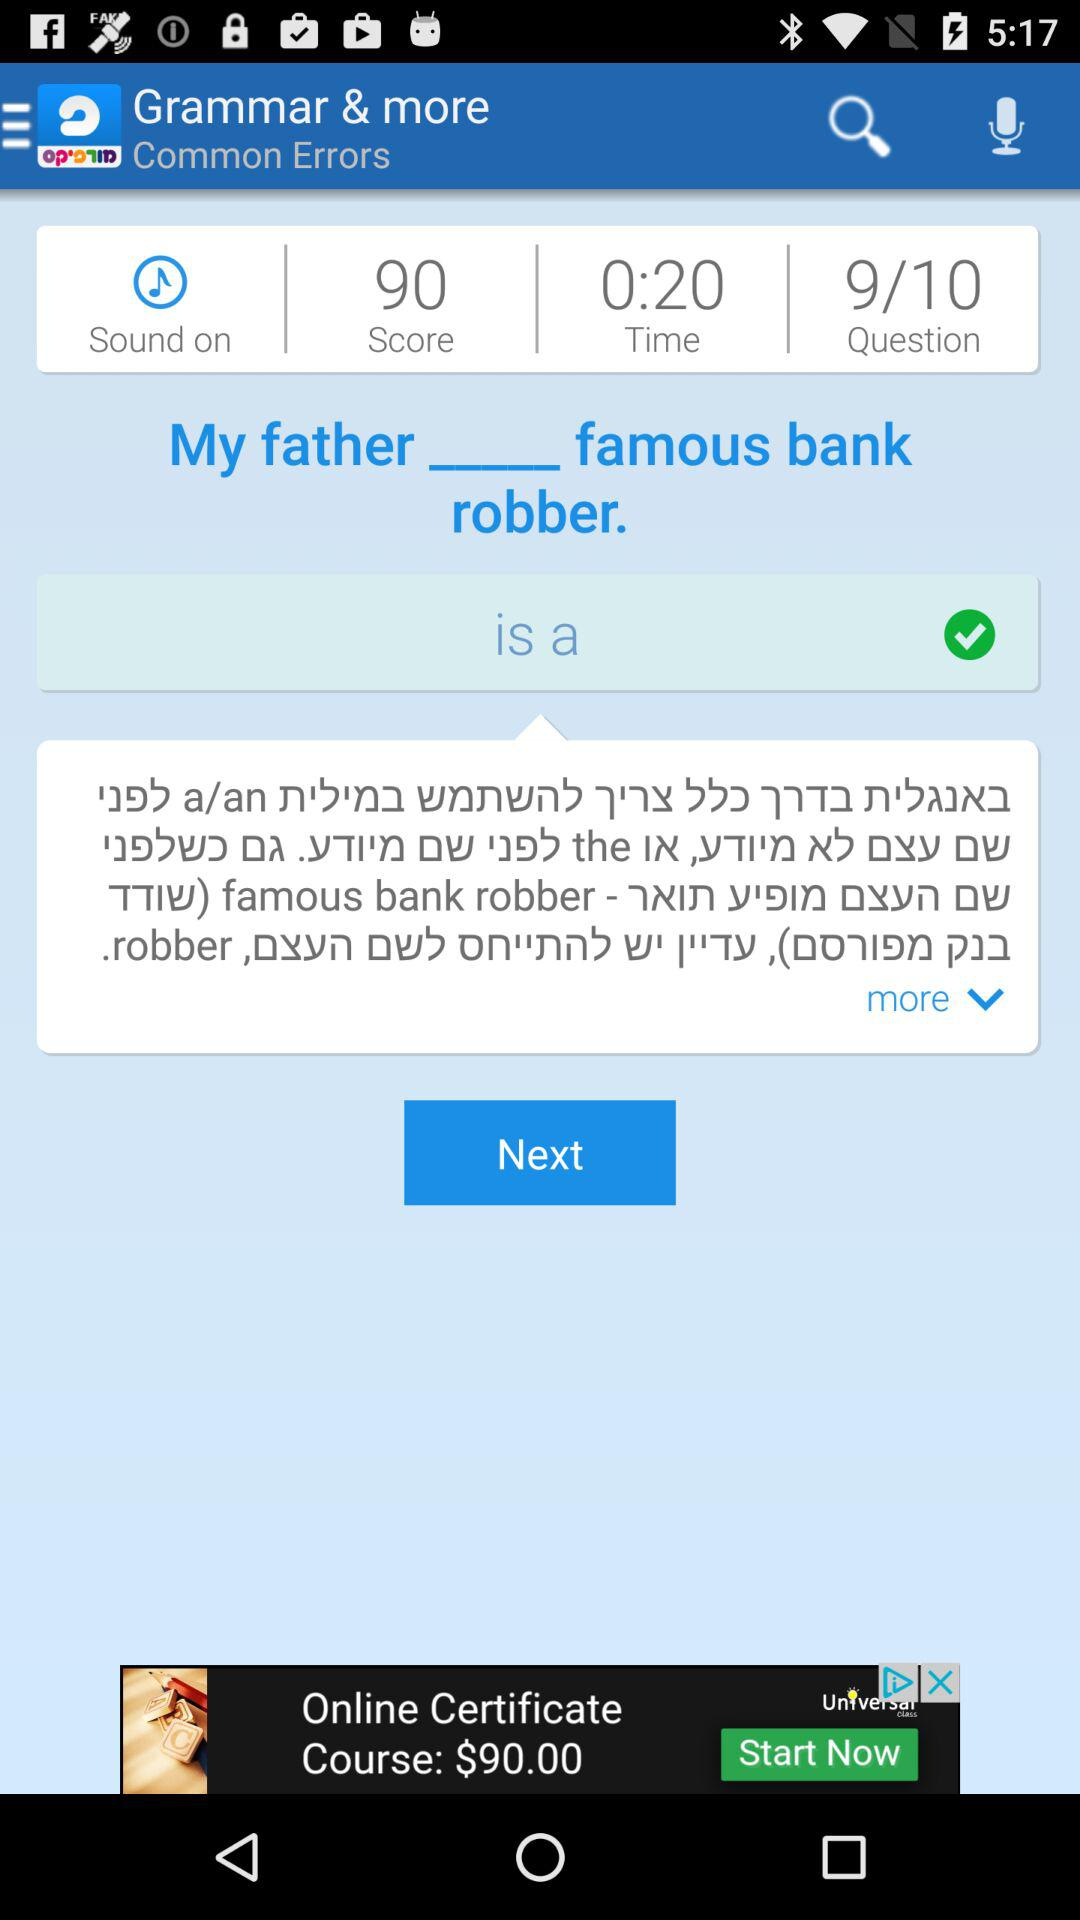What is the score? The score is 90. 